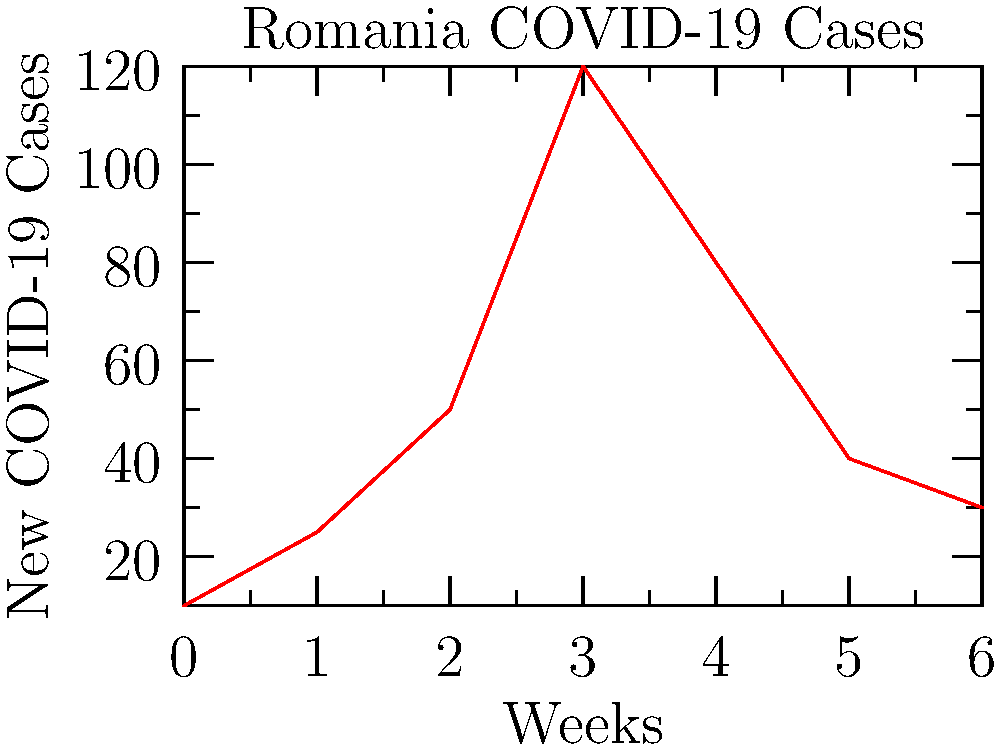As a concerned Romanian public health advocate, analyze the graph showing new COVID-19 cases over a 7-week period. What week shows the highest number of new cases, and what could this indicate about the effectiveness of public health measures? To answer this question, we need to follow these steps:

1. Examine the graph carefully, noting that the x-axis represents weeks and the y-axis represents new COVID-19 cases.

2. Identify the highest point on the graph:
   - Week 0: 10 cases
   - Week 1: 25 cases
   - Week 2: 50 cases
   - Week 3: 120 cases (highest point)
   - Week 4: 80 cases
   - Week 5: 40 cases
   - Week 6: 30 cases

3. The highest number of new cases occurs in Week 3, with 120 cases.

4. Interpret this peak in the context of public health measures:
   - The sharp increase from Week 0 to Week 3 suggests that initial public health measures may not have been sufficient to control the spread of the virus.
   - The peak at Week 3 could indicate a turning point where stricter measures were implemented or existing measures started to take effect.
   - The decline after Week 3 suggests that public health interventions may have become more effective in reducing transmission.

5. As a public health advocate, this data indicates that while there was an initial surge in cases, the subsequent decline shows that public health measures can be effective when properly implemented and followed.
Answer: Week 3; indicates initial measures were insufficient but subsequent interventions likely became more effective. 